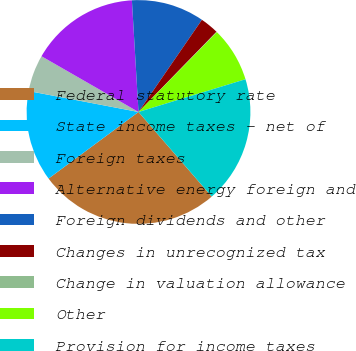<chart> <loc_0><loc_0><loc_500><loc_500><pie_chart><fcel>Federal statutory rate<fcel>State income taxes - net of<fcel>Foreign taxes<fcel>Alternative energy foreign and<fcel>Foreign dividends and other<fcel>Changes in unrecognized tax<fcel>Change in valuation allowance<fcel>Other<fcel>Provision for income taxes<nl><fcel>26.21%<fcel>13.14%<fcel>5.3%<fcel>15.76%<fcel>10.53%<fcel>2.69%<fcel>0.07%<fcel>7.92%<fcel>18.37%<nl></chart> 